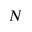<formula> <loc_0><loc_0><loc_500><loc_500>N</formula> 